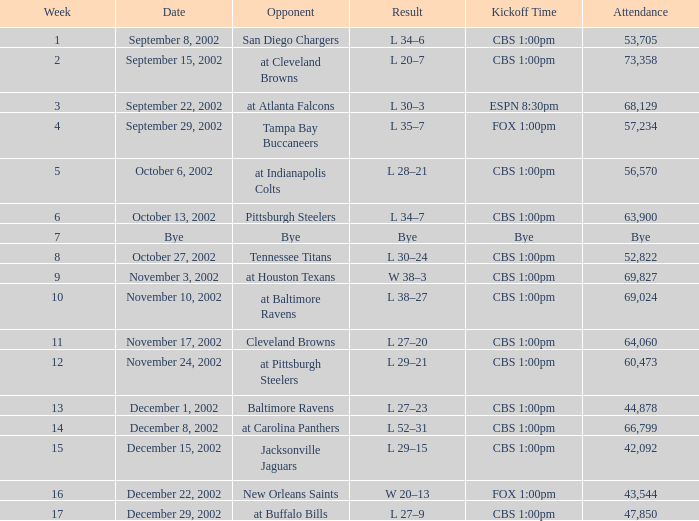What is the result of the game with 57,234 people in attendance? L 35–7. Could you help me parse every detail presented in this table? {'header': ['Week', 'Date', 'Opponent', 'Result', 'Kickoff Time', 'Attendance'], 'rows': [['1', 'September 8, 2002', 'San Diego Chargers', 'L 34–6', 'CBS 1:00pm', '53,705'], ['2', 'September 15, 2002', 'at Cleveland Browns', 'L 20–7', 'CBS 1:00pm', '73,358'], ['3', 'September 22, 2002', 'at Atlanta Falcons', 'L 30–3', 'ESPN 8:30pm', '68,129'], ['4', 'September 29, 2002', 'Tampa Bay Buccaneers', 'L 35–7', 'FOX 1:00pm', '57,234'], ['5', 'October 6, 2002', 'at Indianapolis Colts', 'L 28–21', 'CBS 1:00pm', '56,570'], ['6', 'October 13, 2002', 'Pittsburgh Steelers', 'L 34–7', 'CBS 1:00pm', '63,900'], ['7', 'Bye', 'Bye', 'Bye', 'Bye', 'Bye'], ['8', 'October 27, 2002', 'Tennessee Titans', 'L 30–24', 'CBS 1:00pm', '52,822'], ['9', 'November 3, 2002', 'at Houston Texans', 'W 38–3', 'CBS 1:00pm', '69,827'], ['10', 'November 10, 2002', 'at Baltimore Ravens', 'L 38–27', 'CBS 1:00pm', '69,024'], ['11', 'November 17, 2002', 'Cleveland Browns', 'L 27–20', 'CBS 1:00pm', '64,060'], ['12', 'November 24, 2002', 'at Pittsburgh Steelers', 'L 29–21', 'CBS 1:00pm', '60,473'], ['13', 'December 1, 2002', 'Baltimore Ravens', 'L 27–23', 'CBS 1:00pm', '44,878'], ['14', 'December 8, 2002', 'at Carolina Panthers', 'L 52–31', 'CBS 1:00pm', '66,799'], ['15', 'December 15, 2002', 'Jacksonville Jaguars', 'L 29–15', 'CBS 1:00pm', '42,092'], ['16', 'December 22, 2002', 'New Orleans Saints', 'W 20–13', 'FOX 1:00pm', '43,544'], ['17', 'December 29, 2002', 'at Buffalo Bills', 'L 27–9', 'CBS 1:00pm', '47,850']]} 